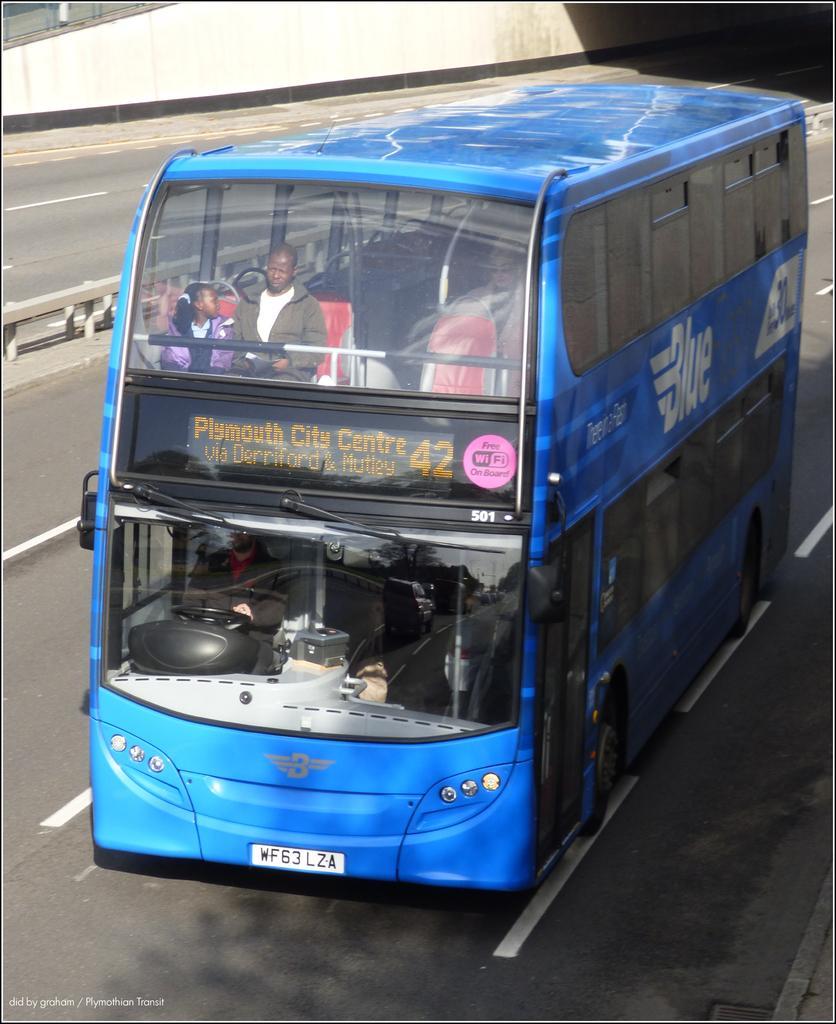How would you summarize this image in a sentence or two? In this image we can see a blue colored double decker bus on a road, there is an led display board which shows some text on the bus and we can see there are two people inside the bus. 